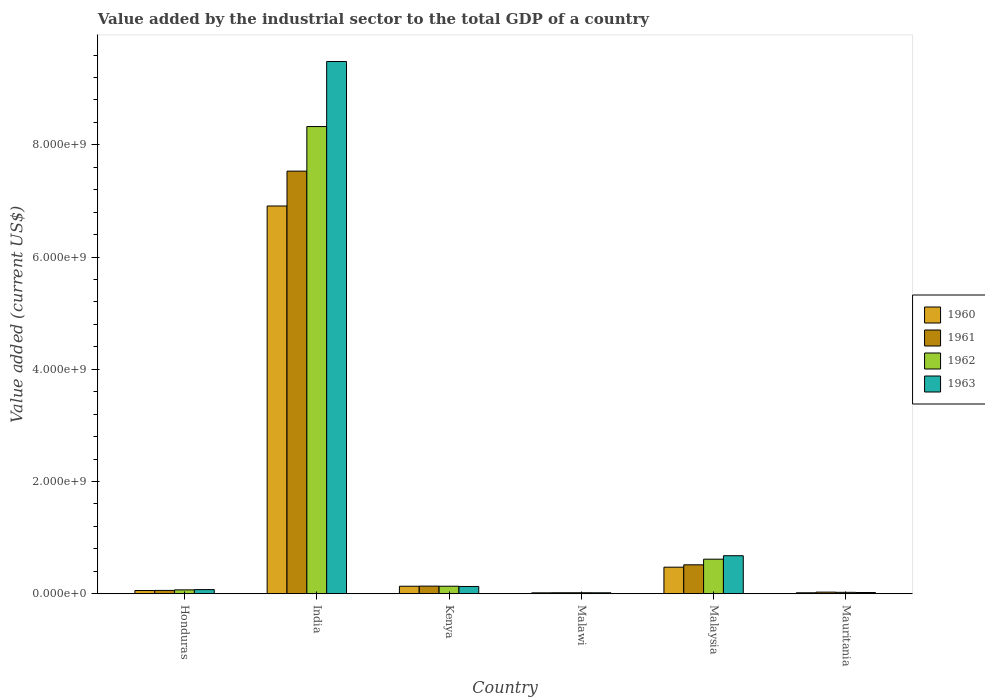How many different coloured bars are there?
Give a very brief answer. 4. How many groups of bars are there?
Your response must be concise. 6. Are the number of bars on each tick of the X-axis equal?
Provide a short and direct response. Yes. How many bars are there on the 1st tick from the left?
Your answer should be compact. 4. In how many cases, is the number of bars for a given country not equal to the number of legend labels?
Make the answer very short. 0. What is the value added by the industrial sector to the total GDP in 1963 in Honduras?
Offer a terse response. 7.38e+07. Across all countries, what is the maximum value added by the industrial sector to the total GDP in 1963?
Your answer should be very brief. 9.49e+09. Across all countries, what is the minimum value added by the industrial sector to the total GDP in 1962?
Your response must be concise. 1.78e+07. In which country was the value added by the industrial sector to the total GDP in 1961 maximum?
Provide a short and direct response. India. In which country was the value added by the industrial sector to the total GDP in 1960 minimum?
Keep it short and to the point. Malawi. What is the total value added by the industrial sector to the total GDP in 1962 in the graph?
Provide a short and direct response. 9.19e+09. What is the difference between the value added by the industrial sector to the total GDP in 1962 in India and that in Kenya?
Make the answer very short. 8.19e+09. What is the difference between the value added by the industrial sector to the total GDP in 1961 in Honduras and the value added by the industrial sector to the total GDP in 1960 in Kenya?
Your response must be concise. -7.43e+07. What is the average value added by the industrial sector to the total GDP in 1961 per country?
Your answer should be very brief. 1.38e+09. What is the difference between the value added by the industrial sector to the total GDP of/in 1960 and value added by the industrial sector to the total GDP of/in 1962 in Kenya?
Offer a terse response. -2.94e+05. What is the ratio of the value added by the industrial sector to the total GDP in 1963 in Malawi to that in Malaysia?
Give a very brief answer. 0.03. Is the difference between the value added by the industrial sector to the total GDP in 1960 in Kenya and Malawi greater than the difference between the value added by the industrial sector to the total GDP in 1962 in Kenya and Malawi?
Keep it short and to the point. Yes. What is the difference between the highest and the second highest value added by the industrial sector to the total GDP in 1961?
Offer a terse response. -3.79e+08. What is the difference between the highest and the lowest value added by the industrial sector to the total GDP in 1961?
Offer a very short reply. 7.51e+09. In how many countries, is the value added by the industrial sector to the total GDP in 1963 greater than the average value added by the industrial sector to the total GDP in 1963 taken over all countries?
Your answer should be compact. 1. Is the sum of the value added by the industrial sector to the total GDP in 1963 in Kenya and Malawi greater than the maximum value added by the industrial sector to the total GDP in 1962 across all countries?
Your answer should be very brief. No. Is it the case that in every country, the sum of the value added by the industrial sector to the total GDP in 1960 and value added by the industrial sector to the total GDP in 1961 is greater than the sum of value added by the industrial sector to the total GDP in 1963 and value added by the industrial sector to the total GDP in 1962?
Make the answer very short. No. What does the 1st bar from the left in Kenya represents?
Give a very brief answer. 1960. What does the 2nd bar from the right in Malaysia represents?
Your answer should be very brief. 1962. How many bars are there?
Your answer should be very brief. 24. Are all the bars in the graph horizontal?
Your answer should be compact. No. How many countries are there in the graph?
Keep it short and to the point. 6. What is the difference between two consecutive major ticks on the Y-axis?
Keep it short and to the point. 2.00e+09. Are the values on the major ticks of Y-axis written in scientific E-notation?
Your answer should be compact. Yes. Does the graph contain any zero values?
Keep it short and to the point. No. Does the graph contain grids?
Make the answer very short. No. What is the title of the graph?
Ensure brevity in your answer.  Value added by the industrial sector to the total GDP of a country. What is the label or title of the Y-axis?
Provide a short and direct response. Value added (current US$). What is the Value added (current US$) in 1960 in Honduras?
Keep it short and to the point. 5.73e+07. What is the Value added (current US$) in 1961 in Honduras?
Give a very brief answer. 5.94e+07. What is the Value added (current US$) of 1962 in Honduras?
Provide a succinct answer. 6.92e+07. What is the Value added (current US$) in 1963 in Honduras?
Make the answer very short. 7.38e+07. What is the Value added (current US$) in 1960 in India?
Give a very brief answer. 6.91e+09. What is the Value added (current US$) of 1961 in India?
Provide a short and direct response. 7.53e+09. What is the Value added (current US$) of 1962 in India?
Keep it short and to the point. 8.33e+09. What is the Value added (current US$) in 1963 in India?
Your answer should be very brief. 9.49e+09. What is the Value added (current US$) of 1960 in Kenya?
Make the answer very short. 1.34e+08. What is the Value added (current US$) of 1961 in Kenya?
Keep it short and to the point. 1.36e+08. What is the Value added (current US$) of 1962 in Kenya?
Provide a succinct answer. 1.34e+08. What is the Value added (current US$) of 1963 in Kenya?
Give a very brief answer. 1.30e+08. What is the Value added (current US$) of 1960 in Malawi?
Your answer should be compact. 1.62e+07. What is the Value added (current US$) in 1961 in Malawi?
Your response must be concise. 1.76e+07. What is the Value added (current US$) in 1962 in Malawi?
Provide a short and direct response. 1.78e+07. What is the Value added (current US$) in 1963 in Malawi?
Offer a very short reply. 1.69e+07. What is the Value added (current US$) in 1960 in Malaysia?
Ensure brevity in your answer.  4.74e+08. What is the Value added (current US$) in 1961 in Malaysia?
Provide a short and direct response. 5.15e+08. What is the Value added (current US$) of 1962 in Malaysia?
Ensure brevity in your answer.  6.16e+08. What is the Value added (current US$) of 1963 in Malaysia?
Provide a succinct answer. 6.77e+08. What is the Value added (current US$) of 1960 in Mauritania?
Keep it short and to the point. 1.73e+07. What is the Value added (current US$) in 1961 in Mauritania?
Provide a short and direct response. 2.88e+07. What is the Value added (current US$) of 1962 in Mauritania?
Provide a succinct answer. 2.52e+07. What is the Value added (current US$) in 1963 in Mauritania?
Make the answer very short. 2.18e+07. Across all countries, what is the maximum Value added (current US$) in 1960?
Offer a terse response. 6.91e+09. Across all countries, what is the maximum Value added (current US$) in 1961?
Provide a short and direct response. 7.53e+09. Across all countries, what is the maximum Value added (current US$) in 1962?
Your answer should be very brief. 8.33e+09. Across all countries, what is the maximum Value added (current US$) of 1963?
Your response must be concise. 9.49e+09. Across all countries, what is the minimum Value added (current US$) of 1960?
Offer a very short reply. 1.62e+07. Across all countries, what is the minimum Value added (current US$) in 1961?
Ensure brevity in your answer.  1.76e+07. Across all countries, what is the minimum Value added (current US$) in 1962?
Keep it short and to the point. 1.78e+07. Across all countries, what is the minimum Value added (current US$) of 1963?
Give a very brief answer. 1.69e+07. What is the total Value added (current US$) of 1960 in the graph?
Provide a succinct answer. 7.61e+09. What is the total Value added (current US$) in 1961 in the graph?
Offer a very short reply. 8.29e+09. What is the total Value added (current US$) in 1962 in the graph?
Your answer should be very brief. 9.19e+09. What is the total Value added (current US$) of 1963 in the graph?
Give a very brief answer. 1.04e+1. What is the difference between the Value added (current US$) of 1960 in Honduras and that in India?
Your response must be concise. -6.85e+09. What is the difference between the Value added (current US$) of 1961 in Honduras and that in India?
Provide a short and direct response. -7.47e+09. What is the difference between the Value added (current US$) in 1962 in Honduras and that in India?
Your answer should be very brief. -8.26e+09. What is the difference between the Value added (current US$) in 1963 in Honduras and that in India?
Ensure brevity in your answer.  -9.41e+09. What is the difference between the Value added (current US$) in 1960 in Honduras and that in Kenya?
Keep it short and to the point. -7.63e+07. What is the difference between the Value added (current US$) in 1961 in Honduras and that in Kenya?
Your response must be concise. -7.65e+07. What is the difference between the Value added (current US$) in 1962 in Honduras and that in Kenya?
Provide a short and direct response. -6.47e+07. What is the difference between the Value added (current US$) in 1963 in Honduras and that in Kenya?
Offer a very short reply. -5.57e+07. What is the difference between the Value added (current US$) of 1960 in Honduras and that in Malawi?
Your response must be concise. 4.11e+07. What is the difference between the Value added (current US$) in 1961 in Honduras and that in Malawi?
Provide a short and direct response. 4.17e+07. What is the difference between the Value added (current US$) in 1962 in Honduras and that in Malawi?
Your answer should be compact. 5.14e+07. What is the difference between the Value added (current US$) of 1963 in Honduras and that in Malawi?
Offer a terse response. 5.69e+07. What is the difference between the Value added (current US$) of 1960 in Honduras and that in Malaysia?
Offer a very short reply. -4.16e+08. What is the difference between the Value added (current US$) of 1961 in Honduras and that in Malaysia?
Offer a terse response. -4.56e+08. What is the difference between the Value added (current US$) of 1962 in Honduras and that in Malaysia?
Your answer should be compact. -5.47e+08. What is the difference between the Value added (current US$) in 1963 in Honduras and that in Malaysia?
Keep it short and to the point. -6.04e+08. What is the difference between the Value added (current US$) in 1960 in Honduras and that in Mauritania?
Offer a very short reply. 4.00e+07. What is the difference between the Value added (current US$) in 1961 in Honduras and that in Mauritania?
Your answer should be compact. 3.05e+07. What is the difference between the Value added (current US$) in 1962 in Honduras and that in Mauritania?
Make the answer very short. 4.40e+07. What is the difference between the Value added (current US$) in 1963 in Honduras and that in Mauritania?
Offer a terse response. 5.20e+07. What is the difference between the Value added (current US$) in 1960 in India and that in Kenya?
Offer a very short reply. 6.78e+09. What is the difference between the Value added (current US$) of 1961 in India and that in Kenya?
Your answer should be very brief. 7.40e+09. What is the difference between the Value added (current US$) in 1962 in India and that in Kenya?
Your answer should be very brief. 8.19e+09. What is the difference between the Value added (current US$) in 1963 in India and that in Kenya?
Your response must be concise. 9.36e+09. What is the difference between the Value added (current US$) of 1960 in India and that in Malawi?
Your response must be concise. 6.89e+09. What is the difference between the Value added (current US$) in 1961 in India and that in Malawi?
Provide a short and direct response. 7.51e+09. What is the difference between the Value added (current US$) in 1962 in India and that in Malawi?
Offer a terse response. 8.31e+09. What is the difference between the Value added (current US$) of 1963 in India and that in Malawi?
Your answer should be very brief. 9.47e+09. What is the difference between the Value added (current US$) in 1960 in India and that in Malaysia?
Offer a terse response. 6.44e+09. What is the difference between the Value added (current US$) of 1961 in India and that in Malaysia?
Give a very brief answer. 7.02e+09. What is the difference between the Value added (current US$) of 1962 in India and that in Malaysia?
Offer a terse response. 7.71e+09. What is the difference between the Value added (current US$) of 1963 in India and that in Malaysia?
Offer a terse response. 8.81e+09. What is the difference between the Value added (current US$) in 1960 in India and that in Mauritania?
Ensure brevity in your answer.  6.89e+09. What is the difference between the Value added (current US$) in 1961 in India and that in Mauritania?
Offer a terse response. 7.50e+09. What is the difference between the Value added (current US$) of 1962 in India and that in Mauritania?
Give a very brief answer. 8.30e+09. What is the difference between the Value added (current US$) of 1963 in India and that in Mauritania?
Give a very brief answer. 9.46e+09. What is the difference between the Value added (current US$) in 1960 in Kenya and that in Malawi?
Offer a very short reply. 1.17e+08. What is the difference between the Value added (current US$) in 1961 in Kenya and that in Malawi?
Your answer should be very brief. 1.18e+08. What is the difference between the Value added (current US$) of 1962 in Kenya and that in Malawi?
Ensure brevity in your answer.  1.16e+08. What is the difference between the Value added (current US$) of 1963 in Kenya and that in Malawi?
Offer a terse response. 1.13e+08. What is the difference between the Value added (current US$) in 1960 in Kenya and that in Malaysia?
Give a very brief answer. -3.40e+08. What is the difference between the Value added (current US$) in 1961 in Kenya and that in Malaysia?
Provide a short and direct response. -3.79e+08. What is the difference between the Value added (current US$) in 1962 in Kenya and that in Malaysia?
Provide a short and direct response. -4.82e+08. What is the difference between the Value added (current US$) in 1963 in Kenya and that in Malaysia?
Offer a very short reply. -5.48e+08. What is the difference between the Value added (current US$) in 1960 in Kenya and that in Mauritania?
Your answer should be compact. 1.16e+08. What is the difference between the Value added (current US$) in 1961 in Kenya and that in Mauritania?
Ensure brevity in your answer.  1.07e+08. What is the difference between the Value added (current US$) of 1962 in Kenya and that in Mauritania?
Give a very brief answer. 1.09e+08. What is the difference between the Value added (current US$) in 1963 in Kenya and that in Mauritania?
Provide a succinct answer. 1.08e+08. What is the difference between the Value added (current US$) in 1960 in Malawi and that in Malaysia?
Offer a very short reply. -4.57e+08. What is the difference between the Value added (current US$) in 1961 in Malawi and that in Malaysia?
Keep it short and to the point. -4.98e+08. What is the difference between the Value added (current US$) in 1962 in Malawi and that in Malaysia?
Give a very brief answer. -5.98e+08. What is the difference between the Value added (current US$) of 1963 in Malawi and that in Malaysia?
Make the answer very short. -6.61e+08. What is the difference between the Value added (current US$) of 1960 in Malawi and that in Mauritania?
Keep it short and to the point. -1.06e+06. What is the difference between the Value added (current US$) of 1961 in Malawi and that in Mauritania?
Ensure brevity in your answer.  -1.12e+07. What is the difference between the Value added (current US$) of 1962 in Malawi and that in Mauritania?
Give a very brief answer. -7.44e+06. What is the difference between the Value added (current US$) in 1963 in Malawi and that in Mauritania?
Offer a terse response. -4.90e+06. What is the difference between the Value added (current US$) of 1960 in Malaysia and that in Mauritania?
Your response must be concise. 4.56e+08. What is the difference between the Value added (current US$) in 1961 in Malaysia and that in Mauritania?
Offer a very short reply. 4.87e+08. What is the difference between the Value added (current US$) of 1962 in Malaysia and that in Mauritania?
Provide a succinct answer. 5.91e+08. What is the difference between the Value added (current US$) of 1963 in Malaysia and that in Mauritania?
Give a very brief answer. 6.56e+08. What is the difference between the Value added (current US$) in 1960 in Honduras and the Value added (current US$) in 1961 in India?
Provide a short and direct response. -7.47e+09. What is the difference between the Value added (current US$) of 1960 in Honduras and the Value added (current US$) of 1962 in India?
Your answer should be very brief. -8.27e+09. What is the difference between the Value added (current US$) in 1960 in Honduras and the Value added (current US$) in 1963 in India?
Provide a succinct answer. -9.43e+09. What is the difference between the Value added (current US$) of 1961 in Honduras and the Value added (current US$) of 1962 in India?
Your answer should be very brief. -8.27e+09. What is the difference between the Value added (current US$) in 1961 in Honduras and the Value added (current US$) in 1963 in India?
Offer a terse response. -9.43e+09. What is the difference between the Value added (current US$) in 1962 in Honduras and the Value added (current US$) in 1963 in India?
Give a very brief answer. -9.42e+09. What is the difference between the Value added (current US$) in 1960 in Honduras and the Value added (current US$) in 1961 in Kenya?
Keep it short and to the point. -7.86e+07. What is the difference between the Value added (current US$) in 1960 in Honduras and the Value added (current US$) in 1962 in Kenya?
Keep it short and to the point. -7.66e+07. What is the difference between the Value added (current US$) of 1960 in Honduras and the Value added (current US$) of 1963 in Kenya?
Ensure brevity in your answer.  -7.22e+07. What is the difference between the Value added (current US$) of 1961 in Honduras and the Value added (current US$) of 1962 in Kenya?
Your response must be concise. -7.46e+07. What is the difference between the Value added (current US$) in 1961 in Honduras and the Value added (current US$) in 1963 in Kenya?
Keep it short and to the point. -7.02e+07. What is the difference between the Value added (current US$) of 1962 in Honduras and the Value added (current US$) of 1963 in Kenya?
Give a very brief answer. -6.03e+07. What is the difference between the Value added (current US$) of 1960 in Honduras and the Value added (current US$) of 1961 in Malawi?
Offer a terse response. 3.97e+07. What is the difference between the Value added (current US$) in 1960 in Honduras and the Value added (current US$) in 1962 in Malawi?
Offer a very short reply. 3.95e+07. What is the difference between the Value added (current US$) of 1960 in Honduras and the Value added (current US$) of 1963 in Malawi?
Your response must be concise. 4.04e+07. What is the difference between the Value added (current US$) in 1961 in Honduras and the Value added (current US$) in 1962 in Malawi?
Keep it short and to the point. 4.16e+07. What is the difference between the Value added (current US$) of 1961 in Honduras and the Value added (current US$) of 1963 in Malawi?
Provide a short and direct response. 4.24e+07. What is the difference between the Value added (current US$) in 1962 in Honduras and the Value added (current US$) in 1963 in Malawi?
Your answer should be compact. 5.23e+07. What is the difference between the Value added (current US$) in 1960 in Honduras and the Value added (current US$) in 1961 in Malaysia?
Make the answer very short. -4.58e+08. What is the difference between the Value added (current US$) in 1960 in Honduras and the Value added (current US$) in 1962 in Malaysia?
Offer a terse response. -5.59e+08. What is the difference between the Value added (current US$) of 1960 in Honduras and the Value added (current US$) of 1963 in Malaysia?
Keep it short and to the point. -6.20e+08. What is the difference between the Value added (current US$) of 1961 in Honduras and the Value added (current US$) of 1962 in Malaysia?
Provide a short and direct response. -5.57e+08. What is the difference between the Value added (current US$) of 1961 in Honduras and the Value added (current US$) of 1963 in Malaysia?
Provide a short and direct response. -6.18e+08. What is the difference between the Value added (current US$) of 1962 in Honduras and the Value added (current US$) of 1963 in Malaysia?
Provide a short and direct response. -6.08e+08. What is the difference between the Value added (current US$) of 1960 in Honduras and the Value added (current US$) of 1961 in Mauritania?
Your response must be concise. 2.85e+07. What is the difference between the Value added (current US$) in 1960 in Honduras and the Value added (current US$) in 1962 in Mauritania?
Provide a short and direct response. 3.21e+07. What is the difference between the Value added (current US$) in 1960 in Honduras and the Value added (current US$) in 1963 in Mauritania?
Make the answer very short. 3.55e+07. What is the difference between the Value added (current US$) in 1961 in Honduras and the Value added (current US$) in 1962 in Mauritania?
Provide a short and direct response. 3.41e+07. What is the difference between the Value added (current US$) of 1961 in Honduras and the Value added (current US$) of 1963 in Mauritania?
Keep it short and to the point. 3.75e+07. What is the difference between the Value added (current US$) in 1962 in Honduras and the Value added (current US$) in 1963 in Mauritania?
Give a very brief answer. 4.74e+07. What is the difference between the Value added (current US$) in 1960 in India and the Value added (current US$) in 1961 in Kenya?
Give a very brief answer. 6.77e+09. What is the difference between the Value added (current US$) of 1960 in India and the Value added (current US$) of 1962 in Kenya?
Your answer should be compact. 6.78e+09. What is the difference between the Value added (current US$) in 1960 in India and the Value added (current US$) in 1963 in Kenya?
Provide a succinct answer. 6.78e+09. What is the difference between the Value added (current US$) of 1961 in India and the Value added (current US$) of 1962 in Kenya?
Your answer should be very brief. 7.40e+09. What is the difference between the Value added (current US$) in 1961 in India and the Value added (current US$) in 1963 in Kenya?
Your answer should be compact. 7.40e+09. What is the difference between the Value added (current US$) of 1962 in India and the Value added (current US$) of 1963 in Kenya?
Your response must be concise. 8.20e+09. What is the difference between the Value added (current US$) of 1960 in India and the Value added (current US$) of 1961 in Malawi?
Provide a short and direct response. 6.89e+09. What is the difference between the Value added (current US$) in 1960 in India and the Value added (current US$) in 1962 in Malawi?
Offer a very short reply. 6.89e+09. What is the difference between the Value added (current US$) in 1960 in India and the Value added (current US$) in 1963 in Malawi?
Your answer should be compact. 6.89e+09. What is the difference between the Value added (current US$) of 1961 in India and the Value added (current US$) of 1962 in Malawi?
Provide a short and direct response. 7.51e+09. What is the difference between the Value added (current US$) in 1961 in India and the Value added (current US$) in 1963 in Malawi?
Your answer should be very brief. 7.51e+09. What is the difference between the Value added (current US$) of 1962 in India and the Value added (current US$) of 1963 in Malawi?
Offer a very short reply. 8.31e+09. What is the difference between the Value added (current US$) of 1960 in India and the Value added (current US$) of 1961 in Malaysia?
Make the answer very short. 6.39e+09. What is the difference between the Value added (current US$) in 1960 in India and the Value added (current US$) in 1962 in Malaysia?
Ensure brevity in your answer.  6.29e+09. What is the difference between the Value added (current US$) in 1960 in India and the Value added (current US$) in 1963 in Malaysia?
Ensure brevity in your answer.  6.23e+09. What is the difference between the Value added (current US$) in 1961 in India and the Value added (current US$) in 1962 in Malaysia?
Provide a succinct answer. 6.92e+09. What is the difference between the Value added (current US$) in 1961 in India and the Value added (current US$) in 1963 in Malaysia?
Your response must be concise. 6.85e+09. What is the difference between the Value added (current US$) in 1962 in India and the Value added (current US$) in 1963 in Malaysia?
Provide a succinct answer. 7.65e+09. What is the difference between the Value added (current US$) in 1960 in India and the Value added (current US$) in 1961 in Mauritania?
Provide a short and direct response. 6.88e+09. What is the difference between the Value added (current US$) in 1960 in India and the Value added (current US$) in 1962 in Mauritania?
Offer a very short reply. 6.88e+09. What is the difference between the Value added (current US$) in 1960 in India and the Value added (current US$) in 1963 in Mauritania?
Provide a short and direct response. 6.89e+09. What is the difference between the Value added (current US$) in 1961 in India and the Value added (current US$) in 1962 in Mauritania?
Provide a short and direct response. 7.51e+09. What is the difference between the Value added (current US$) in 1961 in India and the Value added (current US$) in 1963 in Mauritania?
Give a very brief answer. 7.51e+09. What is the difference between the Value added (current US$) of 1962 in India and the Value added (current US$) of 1963 in Mauritania?
Make the answer very short. 8.30e+09. What is the difference between the Value added (current US$) of 1960 in Kenya and the Value added (current US$) of 1961 in Malawi?
Provide a short and direct response. 1.16e+08. What is the difference between the Value added (current US$) in 1960 in Kenya and the Value added (current US$) in 1962 in Malawi?
Provide a short and direct response. 1.16e+08. What is the difference between the Value added (current US$) in 1960 in Kenya and the Value added (current US$) in 1963 in Malawi?
Your response must be concise. 1.17e+08. What is the difference between the Value added (current US$) of 1961 in Kenya and the Value added (current US$) of 1962 in Malawi?
Your response must be concise. 1.18e+08. What is the difference between the Value added (current US$) of 1961 in Kenya and the Value added (current US$) of 1963 in Malawi?
Provide a succinct answer. 1.19e+08. What is the difference between the Value added (current US$) in 1962 in Kenya and the Value added (current US$) in 1963 in Malawi?
Provide a succinct answer. 1.17e+08. What is the difference between the Value added (current US$) of 1960 in Kenya and the Value added (current US$) of 1961 in Malaysia?
Make the answer very short. -3.82e+08. What is the difference between the Value added (current US$) in 1960 in Kenya and the Value added (current US$) in 1962 in Malaysia?
Offer a terse response. -4.82e+08. What is the difference between the Value added (current US$) of 1960 in Kenya and the Value added (current US$) of 1963 in Malaysia?
Give a very brief answer. -5.44e+08. What is the difference between the Value added (current US$) of 1961 in Kenya and the Value added (current US$) of 1962 in Malaysia?
Ensure brevity in your answer.  -4.80e+08. What is the difference between the Value added (current US$) of 1961 in Kenya and the Value added (current US$) of 1963 in Malaysia?
Your answer should be compact. -5.42e+08. What is the difference between the Value added (current US$) in 1962 in Kenya and the Value added (current US$) in 1963 in Malaysia?
Keep it short and to the point. -5.44e+08. What is the difference between the Value added (current US$) of 1960 in Kenya and the Value added (current US$) of 1961 in Mauritania?
Keep it short and to the point. 1.05e+08. What is the difference between the Value added (current US$) in 1960 in Kenya and the Value added (current US$) in 1962 in Mauritania?
Your answer should be very brief. 1.08e+08. What is the difference between the Value added (current US$) in 1960 in Kenya and the Value added (current US$) in 1963 in Mauritania?
Make the answer very short. 1.12e+08. What is the difference between the Value added (current US$) of 1961 in Kenya and the Value added (current US$) of 1962 in Mauritania?
Provide a succinct answer. 1.11e+08. What is the difference between the Value added (current US$) in 1961 in Kenya and the Value added (current US$) in 1963 in Mauritania?
Ensure brevity in your answer.  1.14e+08. What is the difference between the Value added (current US$) of 1962 in Kenya and the Value added (current US$) of 1963 in Mauritania?
Give a very brief answer. 1.12e+08. What is the difference between the Value added (current US$) of 1960 in Malawi and the Value added (current US$) of 1961 in Malaysia?
Provide a short and direct response. -4.99e+08. What is the difference between the Value added (current US$) of 1960 in Malawi and the Value added (current US$) of 1962 in Malaysia?
Make the answer very short. -6.00e+08. What is the difference between the Value added (current US$) in 1960 in Malawi and the Value added (current US$) in 1963 in Malaysia?
Your response must be concise. -6.61e+08. What is the difference between the Value added (current US$) of 1961 in Malawi and the Value added (current US$) of 1962 in Malaysia?
Provide a short and direct response. -5.98e+08. What is the difference between the Value added (current US$) in 1961 in Malawi and the Value added (current US$) in 1963 in Malaysia?
Give a very brief answer. -6.60e+08. What is the difference between the Value added (current US$) of 1962 in Malawi and the Value added (current US$) of 1963 in Malaysia?
Give a very brief answer. -6.60e+08. What is the difference between the Value added (current US$) in 1960 in Malawi and the Value added (current US$) in 1961 in Mauritania?
Offer a very short reply. -1.26e+07. What is the difference between the Value added (current US$) in 1960 in Malawi and the Value added (current US$) in 1962 in Mauritania?
Make the answer very short. -8.98e+06. What is the difference between the Value added (current US$) of 1960 in Malawi and the Value added (current US$) of 1963 in Mauritania?
Ensure brevity in your answer.  -5.60e+06. What is the difference between the Value added (current US$) in 1961 in Malawi and the Value added (current US$) in 1962 in Mauritania?
Offer a terse response. -7.58e+06. What is the difference between the Value added (current US$) of 1961 in Malawi and the Value added (current US$) of 1963 in Mauritania?
Offer a terse response. -4.20e+06. What is the difference between the Value added (current US$) of 1962 in Malawi and the Value added (current US$) of 1963 in Mauritania?
Offer a terse response. -4.06e+06. What is the difference between the Value added (current US$) in 1960 in Malaysia and the Value added (current US$) in 1961 in Mauritania?
Keep it short and to the point. 4.45e+08. What is the difference between the Value added (current US$) in 1960 in Malaysia and the Value added (current US$) in 1962 in Mauritania?
Provide a succinct answer. 4.48e+08. What is the difference between the Value added (current US$) of 1960 in Malaysia and the Value added (current US$) of 1963 in Mauritania?
Provide a succinct answer. 4.52e+08. What is the difference between the Value added (current US$) of 1961 in Malaysia and the Value added (current US$) of 1962 in Mauritania?
Make the answer very short. 4.90e+08. What is the difference between the Value added (current US$) in 1961 in Malaysia and the Value added (current US$) in 1963 in Mauritania?
Your response must be concise. 4.94e+08. What is the difference between the Value added (current US$) of 1962 in Malaysia and the Value added (current US$) of 1963 in Mauritania?
Provide a succinct answer. 5.94e+08. What is the average Value added (current US$) in 1960 per country?
Provide a succinct answer. 1.27e+09. What is the average Value added (current US$) in 1961 per country?
Your answer should be compact. 1.38e+09. What is the average Value added (current US$) of 1962 per country?
Offer a very short reply. 1.53e+09. What is the average Value added (current US$) in 1963 per country?
Provide a short and direct response. 1.73e+09. What is the difference between the Value added (current US$) in 1960 and Value added (current US$) in 1961 in Honduras?
Provide a succinct answer. -2.05e+06. What is the difference between the Value added (current US$) in 1960 and Value added (current US$) in 1962 in Honduras?
Give a very brief answer. -1.19e+07. What is the difference between the Value added (current US$) of 1960 and Value added (current US$) of 1963 in Honduras?
Keep it short and to the point. -1.65e+07. What is the difference between the Value added (current US$) of 1961 and Value added (current US$) of 1962 in Honduras?
Offer a very short reply. -9.85e+06. What is the difference between the Value added (current US$) of 1961 and Value added (current US$) of 1963 in Honduras?
Provide a short and direct response. -1.44e+07. What is the difference between the Value added (current US$) in 1962 and Value added (current US$) in 1963 in Honduras?
Make the answer very short. -4.60e+06. What is the difference between the Value added (current US$) of 1960 and Value added (current US$) of 1961 in India?
Give a very brief answer. -6.21e+08. What is the difference between the Value added (current US$) of 1960 and Value added (current US$) of 1962 in India?
Give a very brief answer. -1.42e+09. What is the difference between the Value added (current US$) of 1960 and Value added (current US$) of 1963 in India?
Offer a very short reply. -2.58e+09. What is the difference between the Value added (current US$) in 1961 and Value added (current US$) in 1962 in India?
Offer a very short reply. -7.94e+08. What is the difference between the Value added (current US$) of 1961 and Value added (current US$) of 1963 in India?
Your answer should be compact. -1.95e+09. What is the difference between the Value added (current US$) in 1962 and Value added (current US$) in 1963 in India?
Provide a short and direct response. -1.16e+09. What is the difference between the Value added (current US$) in 1960 and Value added (current US$) in 1961 in Kenya?
Give a very brief answer. -2.25e+06. What is the difference between the Value added (current US$) of 1960 and Value added (current US$) of 1962 in Kenya?
Keep it short and to the point. -2.94e+05. What is the difference between the Value added (current US$) in 1960 and Value added (current US$) in 1963 in Kenya?
Ensure brevity in your answer.  4.12e+06. What is the difference between the Value added (current US$) in 1961 and Value added (current US$) in 1962 in Kenya?
Offer a terse response. 1.96e+06. What is the difference between the Value added (current US$) in 1961 and Value added (current US$) in 1963 in Kenya?
Offer a very short reply. 6.37e+06. What is the difference between the Value added (current US$) in 1962 and Value added (current US$) in 1963 in Kenya?
Give a very brief answer. 4.41e+06. What is the difference between the Value added (current US$) of 1960 and Value added (current US$) of 1961 in Malawi?
Your answer should be compact. -1.40e+06. What is the difference between the Value added (current US$) in 1960 and Value added (current US$) in 1962 in Malawi?
Provide a short and direct response. -1.54e+06. What is the difference between the Value added (current US$) in 1960 and Value added (current US$) in 1963 in Malawi?
Offer a terse response. -7.00e+05. What is the difference between the Value added (current US$) of 1961 and Value added (current US$) of 1962 in Malawi?
Your answer should be compact. -1.40e+05. What is the difference between the Value added (current US$) of 1961 and Value added (current US$) of 1963 in Malawi?
Keep it short and to the point. 7.00e+05. What is the difference between the Value added (current US$) in 1962 and Value added (current US$) in 1963 in Malawi?
Your answer should be very brief. 8.40e+05. What is the difference between the Value added (current US$) of 1960 and Value added (current US$) of 1961 in Malaysia?
Offer a very short reply. -4.19e+07. What is the difference between the Value added (current US$) in 1960 and Value added (current US$) in 1962 in Malaysia?
Provide a short and direct response. -1.43e+08. What is the difference between the Value added (current US$) in 1960 and Value added (current US$) in 1963 in Malaysia?
Your answer should be very brief. -2.04e+08. What is the difference between the Value added (current US$) of 1961 and Value added (current US$) of 1962 in Malaysia?
Provide a short and direct response. -1.01e+08. What is the difference between the Value added (current US$) of 1961 and Value added (current US$) of 1963 in Malaysia?
Provide a succinct answer. -1.62e+08. What is the difference between the Value added (current US$) of 1962 and Value added (current US$) of 1963 in Malaysia?
Keep it short and to the point. -6.14e+07. What is the difference between the Value added (current US$) of 1960 and Value added (current US$) of 1961 in Mauritania?
Your answer should be very brief. -1.15e+07. What is the difference between the Value added (current US$) in 1960 and Value added (current US$) in 1962 in Mauritania?
Provide a short and direct response. -7.93e+06. What is the difference between the Value added (current US$) of 1960 and Value added (current US$) of 1963 in Mauritania?
Your answer should be compact. -4.55e+06. What is the difference between the Value added (current US$) in 1961 and Value added (current US$) in 1962 in Mauritania?
Your answer should be compact. 3.60e+06. What is the difference between the Value added (current US$) of 1961 and Value added (current US$) of 1963 in Mauritania?
Provide a succinct answer. 6.98e+06. What is the difference between the Value added (current US$) of 1962 and Value added (current US$) of 1963 in Mauritania?
Make the answer very short. 3.38e+06. What is the ratio of the Value added (current US$) of 1960 in Honduras to that in India?
Your answer should be very brief. 0.01. What is the ratio of the Value added (current US$) of 1961 in Honduras to that in India?
Your answer should be very brief. 0.01. What is the ratio of the Value added (current US$) in 1962 in Honduras to that in India?
Offer a terse response. 0.01. What is the ratio of the Value added (current US$) in 1963 in Honduras to that in India?
Keep it short and to the point. 0.01. What is the ratio of the Value added (current US$) of 1960 in Honduras to that in Kenya?
Keep it short and to the point. 0.43. What is the ratio of the Value added (current US$) in 1961 in Honduras to that in Kenya?
Keep it short and to the point. 0.44. What is the ratio of the Value added (current US$) in 1962 in Honduras to that in Kenya?
Offer a terse response. 0.52. What is the ratio of the Value added (current US$) of 1963 in Honduras to that in Kenya?
Your answer should be compact. 0.57. What is the ratio of the Value added (current US$) of 1960 in Honduras to that in Malawi?
Your answer should be very brief. 3.53. What is the ratio of the Value added (current US$) of 1961 in Honduras to that in Malawi?
Offer a very short reply. 3.36. What is the ratio of the Value added (current US$) of 1962 in Honduras to that in Malawi?
Your answer should be compact. 3.89. What is the ratio of the Value added (current US$) in 1963 in Honduras to that in Malawi?
Ensure brevity in your answer.  4.36. What is the ratio of the Value added (current US$) of 1960 in Honduras to that in Malaysia?
Your response must be concise. 0.12. What is the ratio of the Value added (current US$) of 1961 in Honduras to that in Malaysia?
Make the answer very short. 0.12. What is the ratio of the Value added (current US$) of 1962 in Honduras to that in Malaysia?
Offer a terse response. 0.11. What is the ratio of the Value added (current US$) of 1963 in Honduras to that in Malaysia?
Your response must be concise. 0.11. What is the ratio of the Value added (current US$) in 1960 in Honduras to that in Mauritania?
Your answer should be very brief. 3.31. What is the ratio of the Value added (current US$) in 1961 in Honduras to that in Mauritania?
Offer a terse response. 2.06. What is the ratio of the Value added (current US$) of 1962 in Honduras to that in Mauritania?
Keep it short and to the point. 2.74. What is the ratio of the Value added (current US$) of 1963 in Honduras to that in Mauritania?
Give a very brief answer. 3.38. What is the ratio of the Value added (current US$) of 1960 in India to that in Kenya?
Offer a terse response. 51.7. What is the ratio of the Value added (current US$) of 1961 in India to that in Kenya?
Make the answer very short. 55.42. What is the ratio of the Value added (current US$) of 1962 in India to that in Kenya?
Give a very brief answer. 62.16. What is the ratio of the Value added (current US$) of 1963 in India to that in Kenya?
Give a very brief answer. 73.23. What is the ratio of the Value added (current US$) in 1960 in India to that in Malawi?
Give a very brief answer. 425.49. What is the ratio of the Value added (current US$) of 1961 in India to that in Malawi?
Keep it short and to the point. 426.94. What is the ratio of the Value added (current US$) in 1962 in India to that in Malawi?
Make the answer very short. 468.26. What is the ratio of the Value added (current US$) of 1963 in India to that in Malawi?
Give a very brief answer. 559.94. What is the ratio of the Value added (current US$) in 1960 in India to that in Malaysia?
Ensure brevity in your answer.  14.59. What is the ratio of the Value added (current US$) in 1961 in India to that in Malaysia?
Provide a short and direct response. 14.61. What is the ratio of the Value added (current US$) of 1962 in India to that in Malaysia?
Give a very brief answer. 13.51. What is the ratio of the Value added (current US$) in 1963 in India to that in Malaysia?
Offer a very short reply. 14. What is the ratio of the Value added (current US$) of 1960 in India to that in Mauritania?
Keep it short and to the point. 399.54. What is the ratio of the Value added (current US$) in 1961 in India to that in Mauritania?
Ensure brevity in your answer.  261.27. What is the ratio of the Value added (current US$) of 1962 in India to that in Mauritania?
Provide a succinct answer. 330.1. What is the ratio of the Value added (current US$) of 1963 in India to that in Mauritania?
Your answer should be compact. 434.24. What is the ratio of the Value added (current US$) of 1960 in Kenya to that in Malawi?
Offer a very short reply. 8.23. What is the ratio of the Value added (current US$) of 1961 in Kenya to that in Malawi?
Offer a terse response. 7.7. What is the ratio of the Value added (current US$) in 1962 in Kenya to that in Malawi?
Give a very brief answer. 7.53. What is the ratio of the Value added (current US$) in 1963 in Kenya to that in Malawi?
Provide a short and direct response. 7.65. What is the ratio of the Value added (current US$) of 1960 in Kenya to that in Malaysia?
Ensure brevity in your answer.  0.28. What is the ratio of the Value added (current US$) of 1961 in Kenya to that in Malaysia?
Keep it short and to the point. 0.26. What is the ratio of the Value added (current US$) in 1962 in Kenya to that in Malaysia?
Ensure brevity in your answer.  0.22. What is the ratio of the Value added (current US$) in 1963 in Kenya to that in Malaysia?
Give a very brief answer. 0.19. What is the ratio of the Value added (current US$) in 1960 in Kenya to that in Mauritania?
Your answer should be compact. 7.73. What is the ratio of the Value added (current US$) of 1961 in Kenya to that in Mauritania?
Your answer should be very brief. 4.71. What is the ratio of the Value added (current US$) of 1962 in Kenya to that in Mauritania?
Offer a very short reply. 5.31. What is the ratio of the Value added (current US$) in 1963 in Kenya to that in Mauritania?
Ensure brevity in your answer.  5.93. What is the ratio of the Value added (current US$) in 1960 in Malawi to that in Malaysia?
Offer a very short reply. 0.03. What is the ratio of the Value added (current US$) in 1961 in Malawi to that in Malaysia?
Your response must be concise. 0.03. What is the ratio of the Value added (current US$) in 1962 in Malawi to that in Malaysia?
Your response must be concise. 0.03. What is the ratio of the Value added (current US$) in 1963 in Malawi to that in Malaysia?
Offer a very short reply. 0.03. What is the ratio of the Value added (current US$) in 1960 in Malawi to that in Mauritania?
Make the answer very short. 0.94. What is the ratio of the Value added (current US$) of 1961 in Malawi to that in Mauritania?
Offer a terse response. 0.61. What is the ratio of the Value added (current US$) in 1962 in Malawi to that in Mauritania?
Provide a short and direct response. 0.7. What is the ratio of the Value added (current US$) of 1963 in Malawi to that in Mauritania?
Provide a succinct answer. 0.78. What is the ratio of the Value added (current US$) of 1960 in Malaysia to that in Mauritania?
Give a very brief answer. 27.38. What is the ratio of the Value added (current US$) in 1961 in Malaysia to that in Mauritania?
Your answer should be compact. 17.88. What is the ratio of the Value added (current US$) of 1962 in Malaysia to that in Mauritania?
Your answer should be compact. 24.43. What is the ratio of the Value added (current US$) of 1963 in Malaysia to that in Mauritania?
Offer a terse response. 31.01. What is the difference between the highest and the second highest Value added (current US$) of 1960?
Offer a very short reply. 6.44e+09. What is the difference between the highest and the second highest Value added (current US$) of 1961?
Provide a short and direct response. 7.02e+09. What is the difference between the highest and the second highest Value added (current US$) of 1962?
Ensure brevity in your answer.  7.71e+09. What is the difference between the highest and the second highest Value added (current US$) of 1963?
Your answer should be compact. 8.81e+09. What is the difference between the highest and the lowest Value added (current US$) of 1960?
Your answer should be very brief. 6.89e+09. What is the difference between the highest and the lowest Value added (current US$) of 1961?
Provide a short and direct response. 7.51e+09. What is the difference between the highest and the lowest Value added (current US$) in 1962?
Provide a succinct answer. 8.31e+09. What is the difference between the highest and the lowest Value added (current US$) of 1963?
Offer a very short reply. 9.47e+09. 